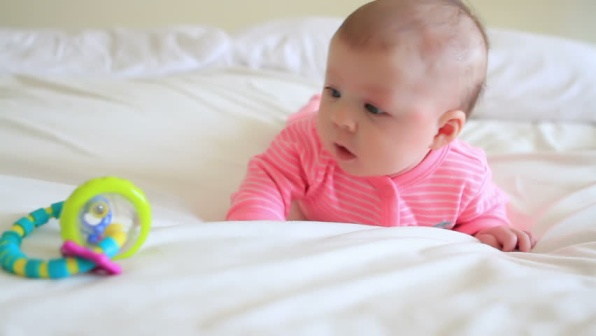Describe the setting and mood of this image. The setting of the image is serene and gentle, with the baby lying on a white bedspread that evokes a sense of calm and purity. The natural lighting enhances the soft atmosphere, making the scene feel warm and inviting. The baby's focus on the colorful rattle adds a touch of innocence and curiosity, creating a mood that is both tender and heartwarming. 